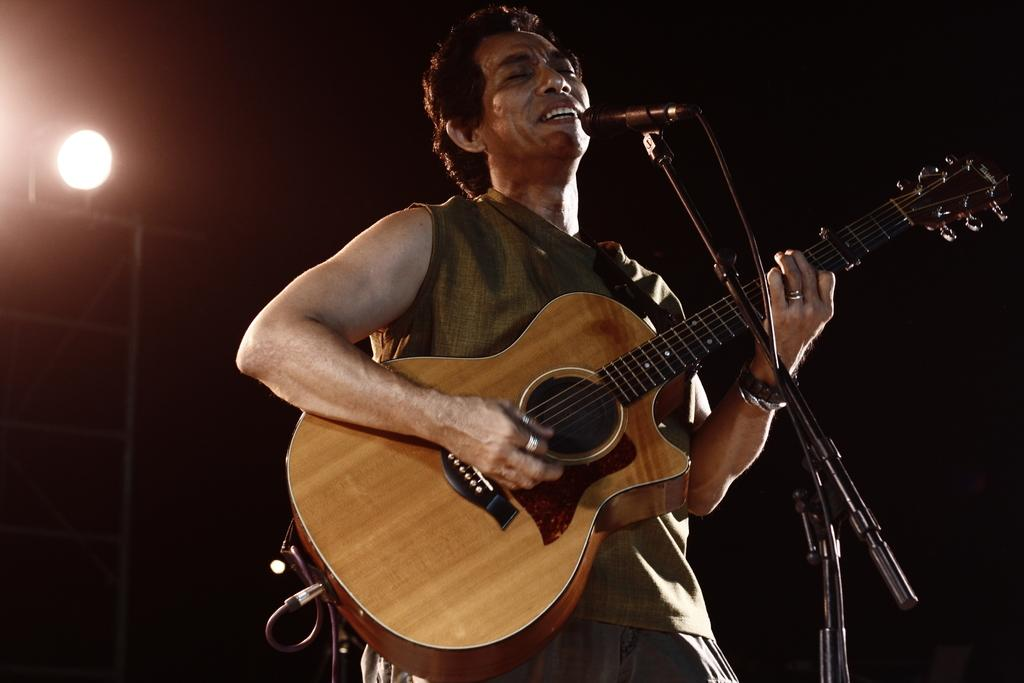What is the man in the image doing? The man is standing, holding a guitar, and singing into a microphone. What object is the man holding in the image? The man is holding a guitar. What can be seen in the background of the image? There is a stand with a light on it in the background. What is the man using to amplify his voice? The man is singing into a microphone. What type of baseball is the man wearing in the image? There is no baseball or any clothing item resembling a baseball in the image. What color is the skirt the man is wearing in the image? The man is not wearing a skirt in the image. What sound can be heard coming from the alarm in the image? There is no alarm present in the image. 